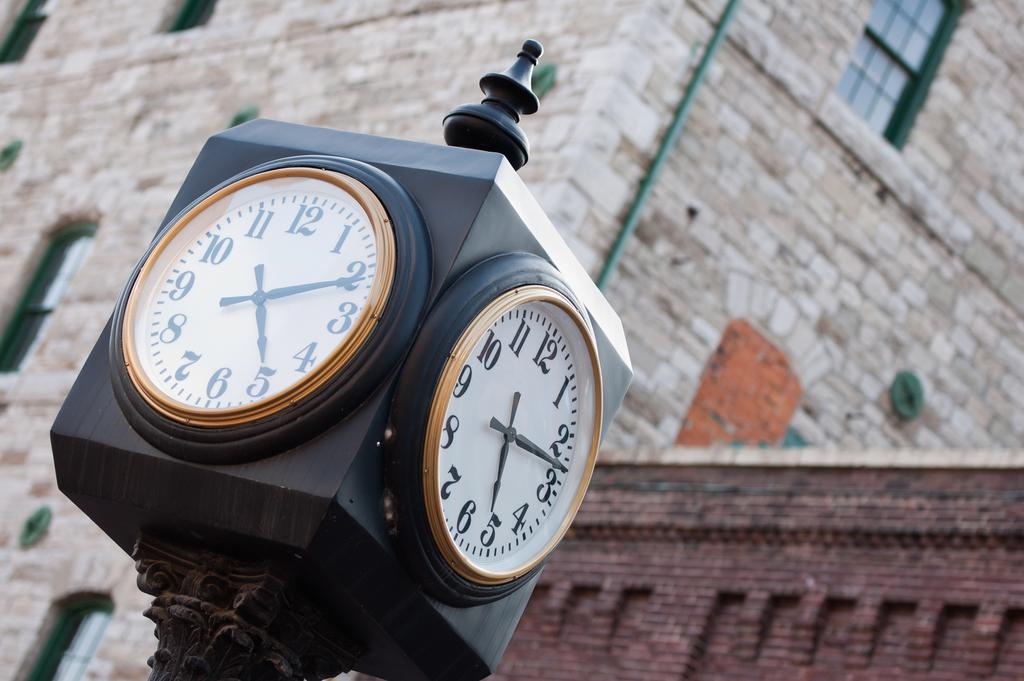<image>
Offer a succinct explanation of the picture presented. A tower clock showing the approximate time of 5:13. 